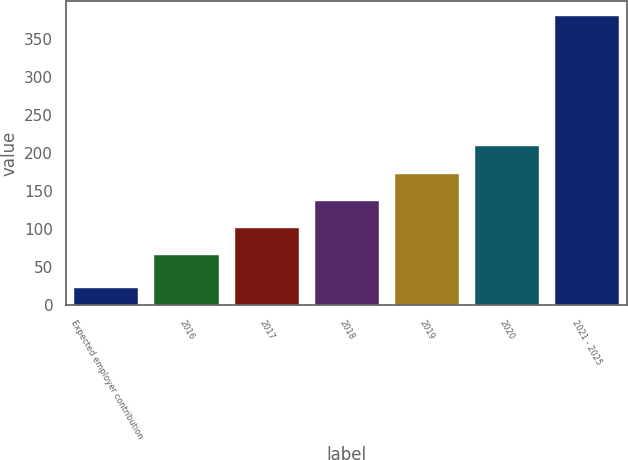<chart> <loc_0><loc_0><loc_500><loc_500><bar_chart><fcel>Expected employer contribution<fcel>2016<fcel>2017<fcel>2018<fcel>2019<fcel>2020<fcel>2021 - 2025<nl><fcel>22<fcel>65<fcel>100.8<fcel>136.6<fcel>172.4<fcel>208.2<fcel>380<nl></chart> 